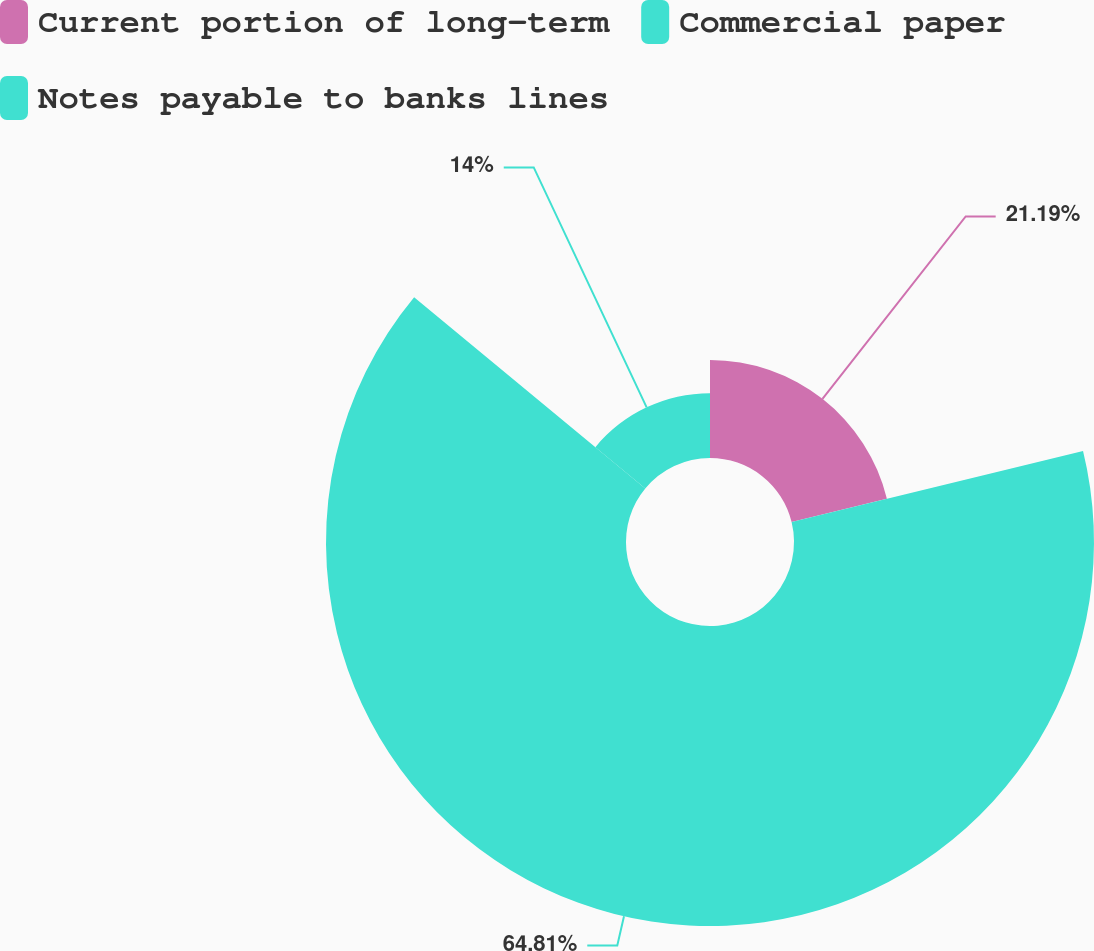Convert chart. <chart><loc_0><loc_0><loc_500><loc_500><pie_chart><fcel>Current portion of long-term<fcel>Commercial paper<fcel>Notes payable to banks lines<nl><fcel>21.19%<fcel>64.81%<fcel>14.0%<nl></chart> 